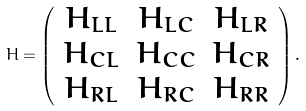Convert formula to latex. <formula><loc_0><loc_0><loc_500><loc_500>H = \left ( \begin{array} { c c c } H _ { L L } & H _ { L C } & H _ { L R } \\ H _ { C L } & H _ { C C } & H _ { C R } \\ H _ { R L } & H _ { R C } & H _ { R R } \end{array} \right ) .</formula> 